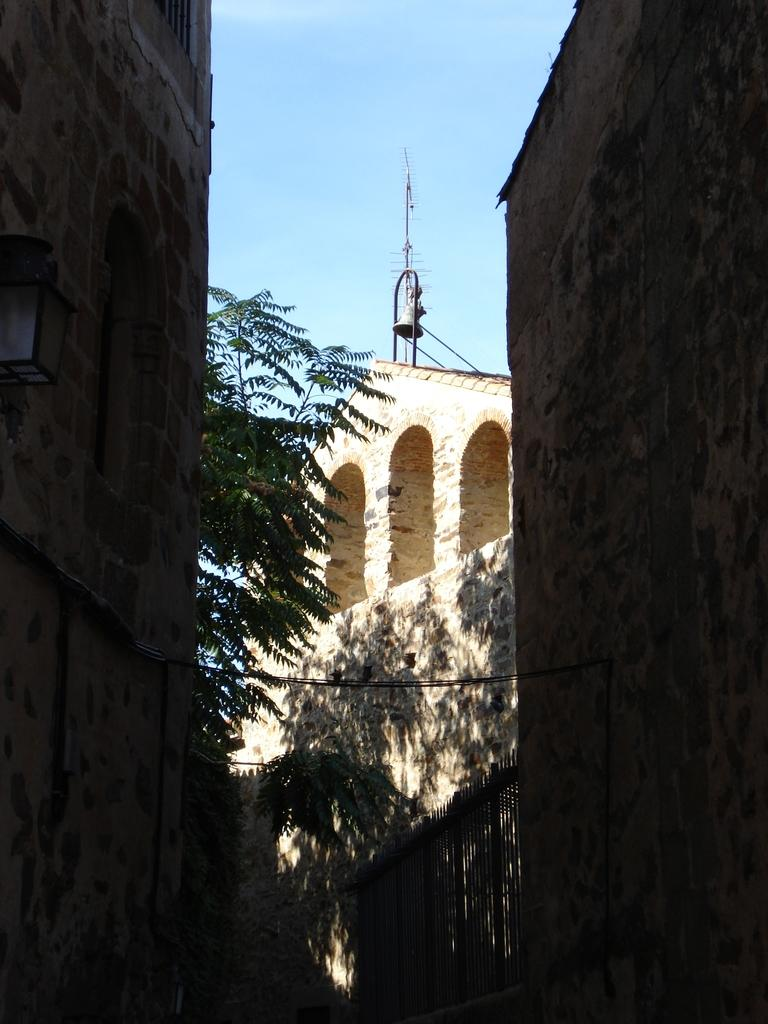What type of structures can be seen in the image? There are buildings in the image. What object is hanging from the pole in the image? There is a bell hanging from the pole in the image. What is the tall, vertical object in the image? There is a pole in the image. What type of plant is present in the image? There is a tree in the image. What is the source of light in the image? There is a lamp in the image. What type of cooking equipment is present in the image? There are grills in the image. What is the large, flat surface in the image? There is a wall in the image. What can be seen in the sky at the top of the image? Clouds are present in the sky at the top of the image. How many feet are visible on the wall in the image? There are no feet visible on the wall in the image. What type of glass object is present in the image? There is no glass object present in the image. 